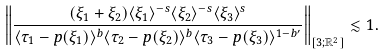Convert formula to latex. <formula><loc_0><loc_0><loc_500><loc_500>\left \| \frac { ( \xi _ { 1 } + \xi _ { 2 } ) \langle \xi _ { 1 } \rangle ^ { - s } \langle \xi _ { 2 } \rangle ^ { - s } \langle \xi _ { 3 } \rangle ^ { s } } { \langle \tau _ { 1 } - p ( \xi _ { 1 } ) \rangle ^ { b } \langle \tau _ { 2 } - p ( \xi _ { 2 } ) \rangle ^ { b } \langle \tau _ { 3 } - p ( \xi _ { 3 } ) \rangle ^ { 1 - b ^ { \prime } } } \right \| _ { [ 3 ; \mathbb { R } ^ { 2 } ] } \lesssim 1 .</formula> 